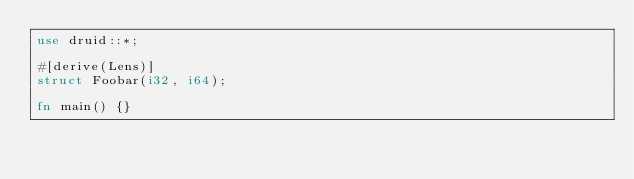Convert code to text. <code><loc_0><loc_0><loc_500><loc_500><_Rust_>use druid::*;

#[derive(Lens)]
struct Foobar(i32, i64);

fn main() {}
</code> 